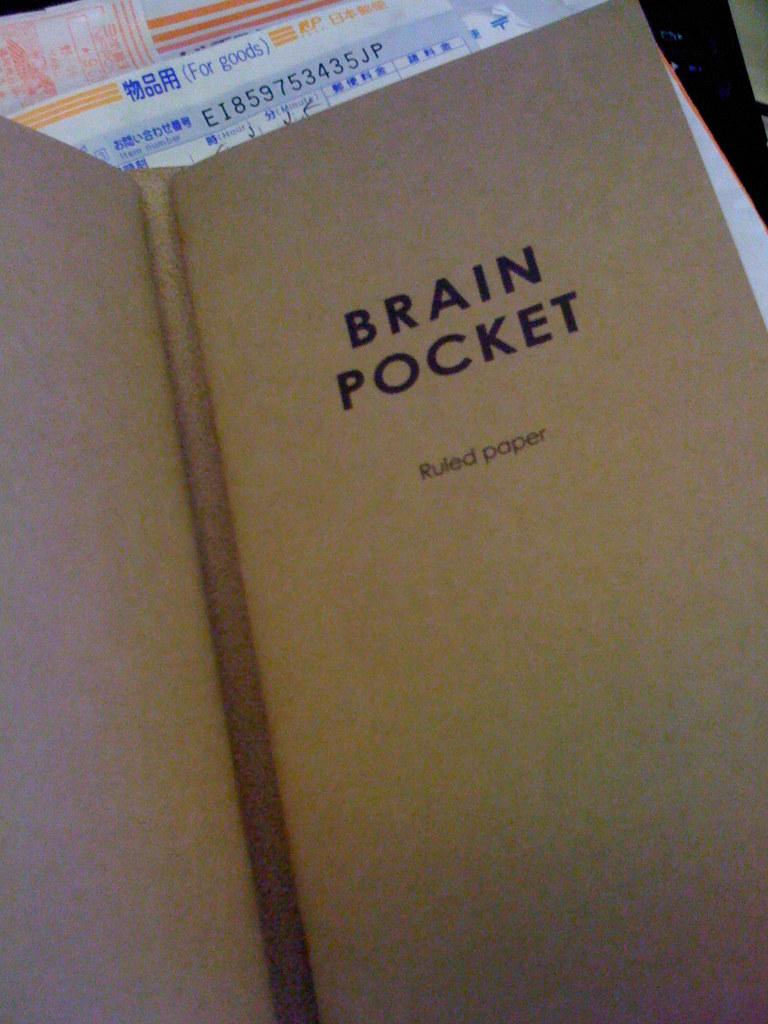What is the name of the book?
Ensure brevity in your answer.  Brain pocket. What type of paper?
Provide a succinct answer. Ruled. 